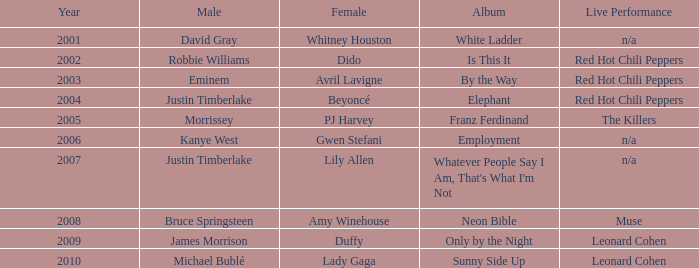Which female singer released an album called "elephant"? Beyoncé. 